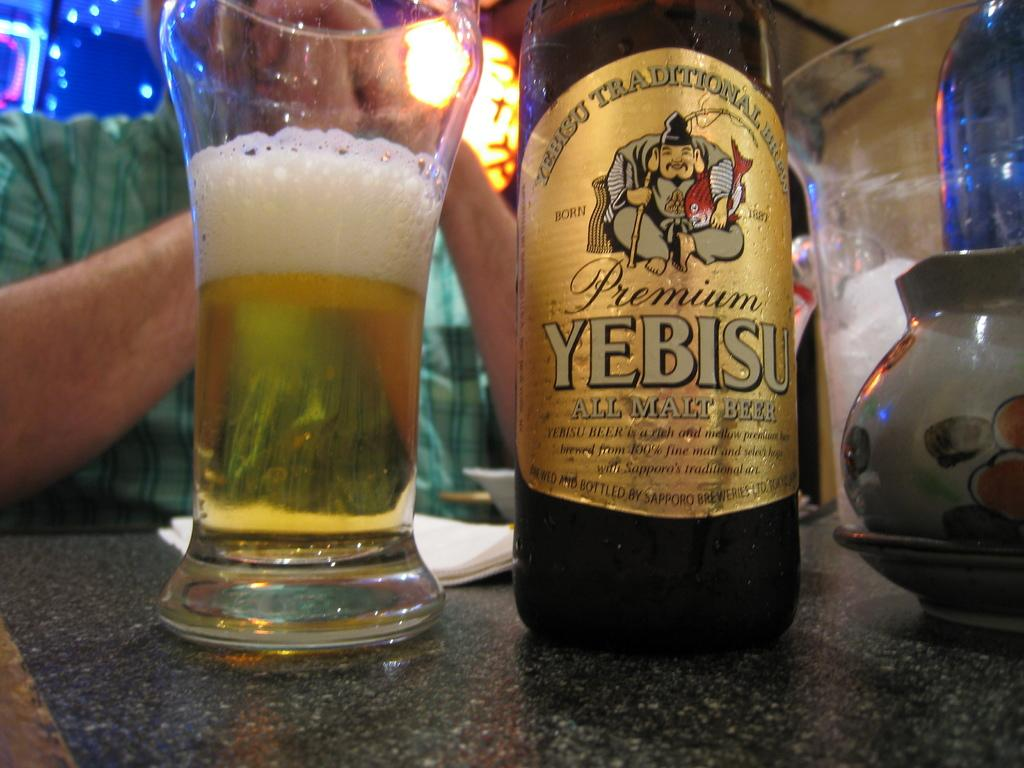<image>
Create a compact narrative representing the image presented. A bottle of beer is labeled Premium Yebisu. 